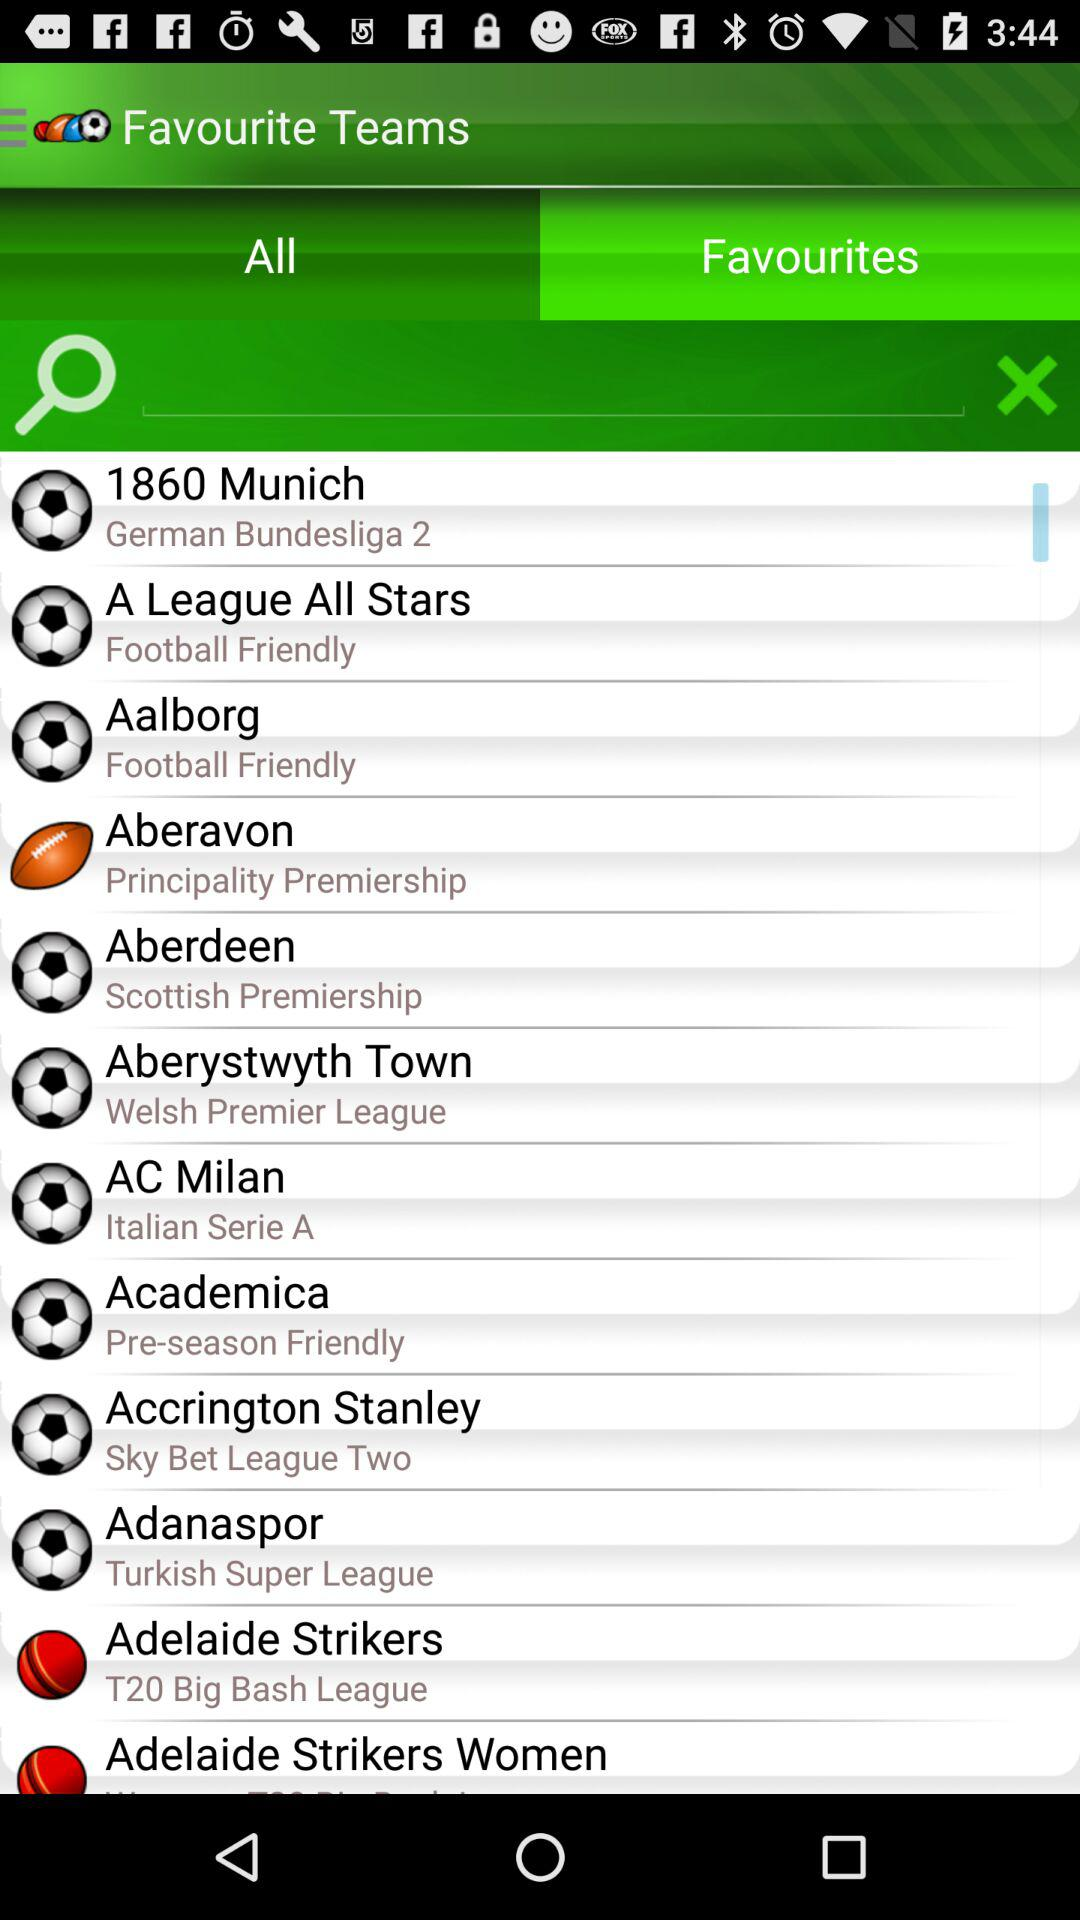What are the available favourite teams? The available favourite teams are "1860 Munich", "A League All Stars", "Aalborg", "Aberavon", "Aberdeen", "Aberystwyth Town", "AC Milan", "Academica", "Accrington Stanley", "Adanaspor", "Adelaide Strikers" and "Adelaide Strikers Women". 